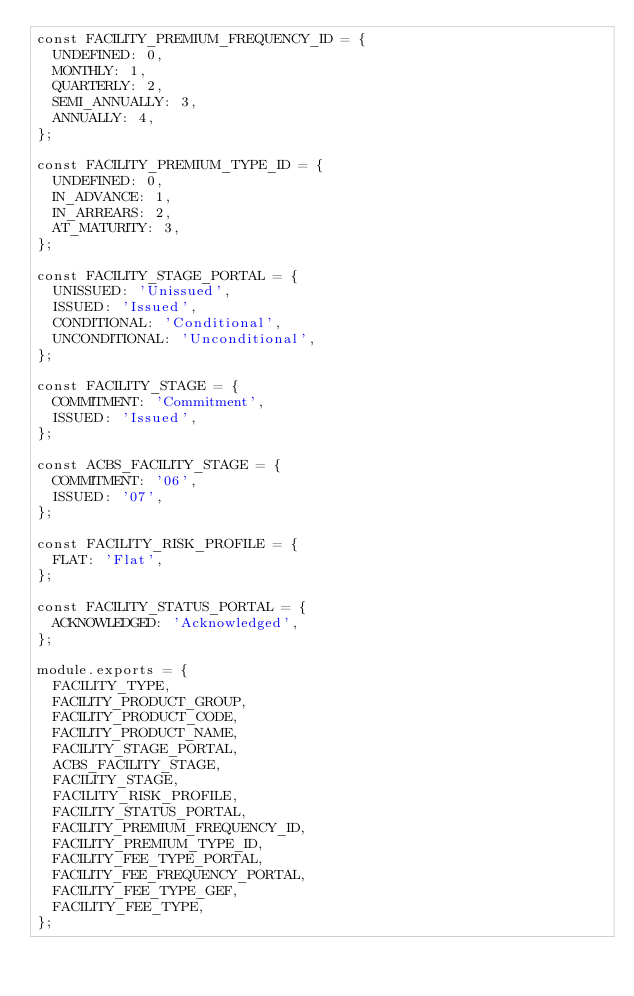Convert code to text. <code><loc_0><loc_0><loc_500><loc_500><_JavaScript_>const FACILITY_PREMIUM_FREQUENCY_ID = {
  UNDEFINED: 0,
  MONTHLY: 1,
  QUARTERLY: 2,
  SEMI_ANNUALLY: 3,
  ANNUALLY: 4,
};

const FACILITY_PREMIUM_TYPE_ID = {
  UNDEFINED: 0,
  IN_ADVANCE: 1,
  IN_ARREARS: 2,
  AT_MATURITY: 3,
};

const FACILITY_STAGE_PORTAL = {
  UNISSUED: 'Unissued',
  ISSUED: 'Issued',
  CONDITIONAL: 'Conditional',
  UNCONDITIONAL: 'Unconditional',
};

const FACILITY_STAGE = {
  COMMITMENT: 'Commitment',
  ISSUED: 'Issued',
};

const ACBS_FACILITY_STAGE = {
  COMMITMENT: '06',
  ISSUED: '07',
};

const FACILITY_RISK_PROFILE = {
  FLAT: 'Flat',
};

const FACILITY_STATUS_PORTAL = {
  ACKNOWLEDGED: 'Acknowledged',
};

module.exports = {
  FACILITY_TYPE,
  FACILITY_PRODUCT_GROUP,
  FACILITY_PRODUCT_CODE,
  FACILITY_PRODUCT_NAME,
  FACILITY_STAGE_PORTAL,
  ACBS_FACILITY_STAGE,
  FACILITY_STAGE,
  FACILITY_RISK_PROFILE,
  FACILITY_STATUS_PORTAL,
  FACILITY_PREMIUM_FREQUENCY_ID,
  FACILITY_PREMIUM_TYPE_ID,
  FACILITY_FEE_TYPE_PORTAL,
  FACILITY_FEE_FREQUENCY_PORTAL,
  FACILITY_FEE_TYPE_GEF,
  FACILITY_FEE_TYPE,
};
</code> 